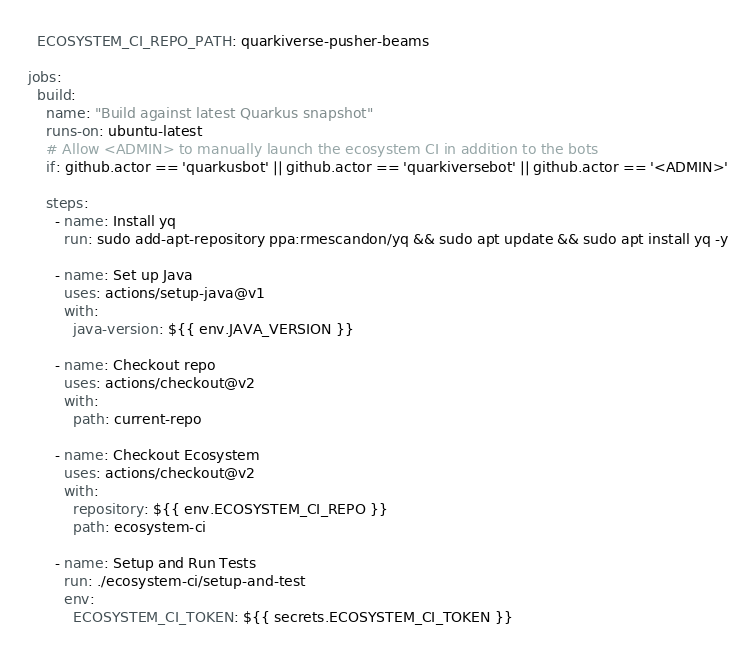<code> <loc_0><loc_0><loc_500><loc_500><_YAML_>  ECOSYSTEM_CI_REPO_PATH: quarkiverse-pusher-beams

jobs:
  build:
    name: "Build against latest Quarkus snapshot"
    runs-on: ubuntu-latest
    # Allow <ADMIN> to manually launch the ecosystem CI in addition to the bots
    if: github.actor == 'quarkusbot' || github.actor == 'quarkiversebot' || github.actor == '<ADMIN>'

    steps:
      - name: Install yq
        run: sudo add-apt-repository ppa:rmescandon/yq && sudo apt update && sudo apt install yq -y

      - name: Set up Java
        uses: actions/setup-java@v1
        with:
          java-version: ${{ env.JAVA_VERSION }}

      - name: Checkout repo
        uses: actions/checkout@v2
        with:
          path: current-repo

      - name: Checkout Ecosystem
        uses: actions/checkout@v2
        with:
          repository: ${{ env.ECOSYSTEM_CI_REPO }}
          path: ecosystem-ci

      - name: Setup and Run Tests
        run: ./ecosystem-ci/setup-and-test
        env:
          ECOSYSTEM_CI_TOKEN: ${{ secrets.ECOSYSTEM_CI_TOKEN }}
</code> 